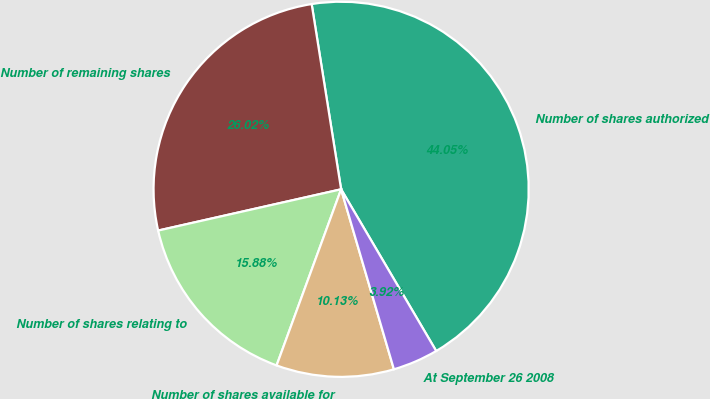Convert chart. <chart><loc_0><loc_0><loc_500><loc_500><pie_chart><fcel>Number of shares authorized<fcel>Number of remaining shares<fcel>Number of shares relating to<fcel>Number of shares available for<fcel>At September 26 2008<nl><fcel>44.05%<fcel>26.02%<fcel>15.88%<fcel>10.13%<fcel>3.92%<nl></chart> 